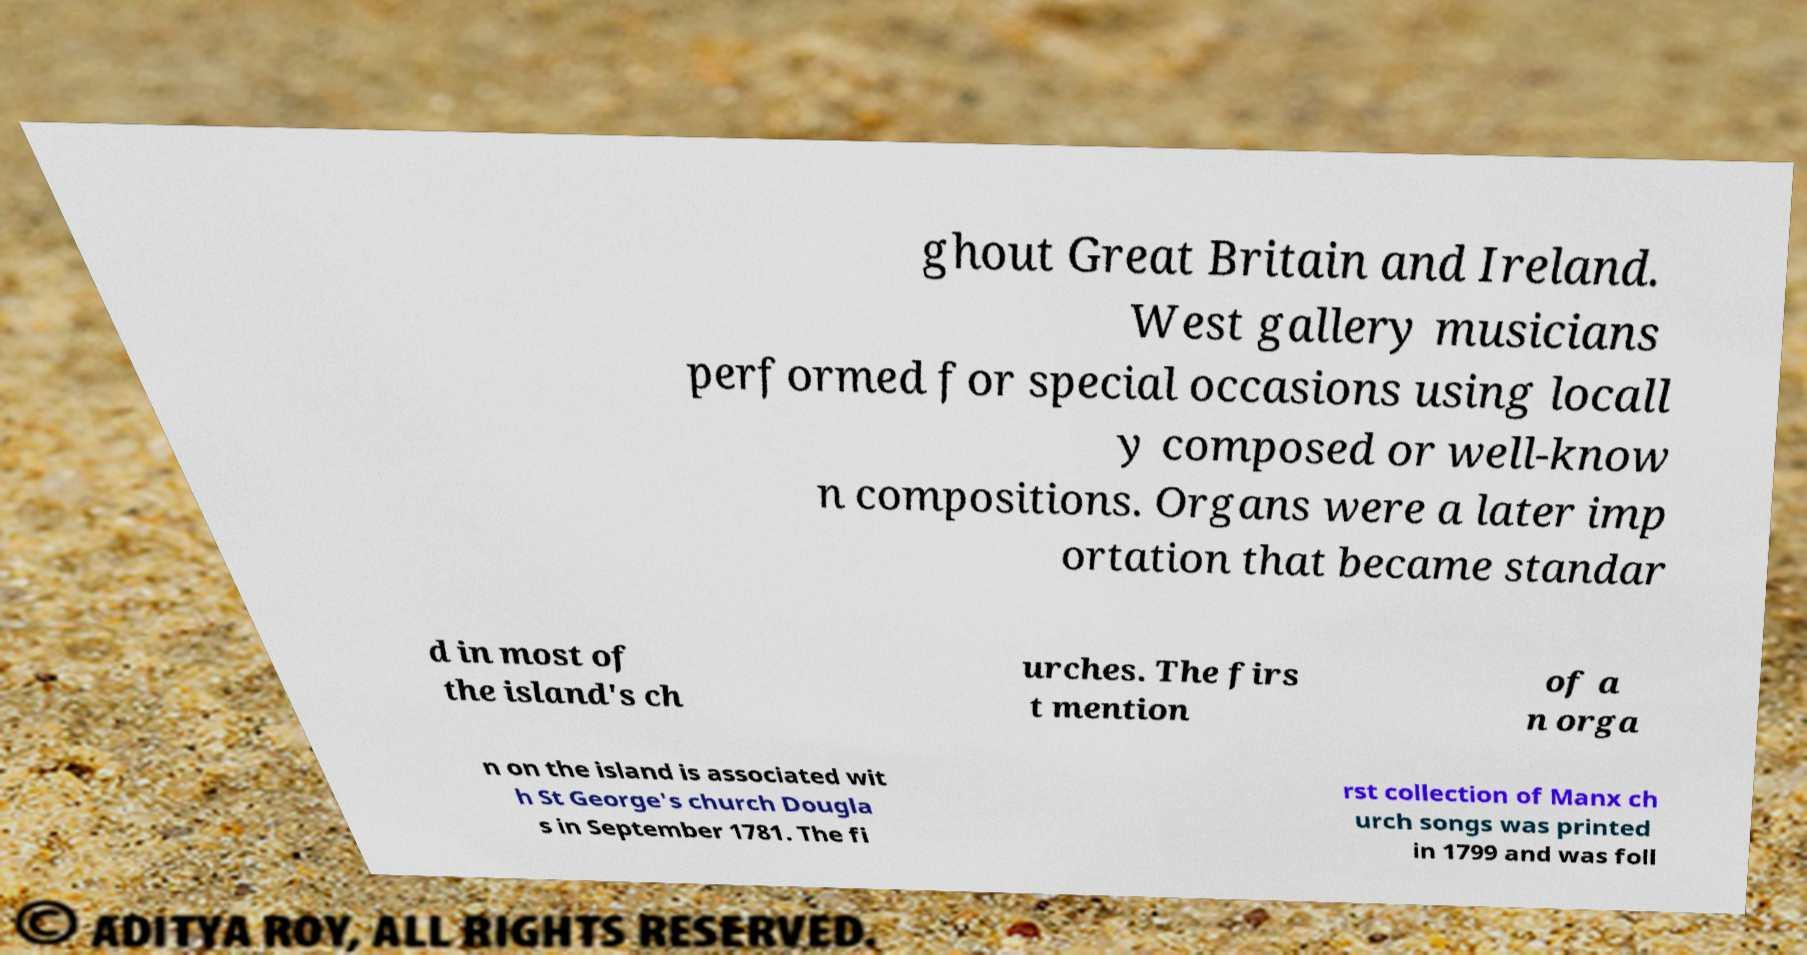There's text embedded in this image that I need extracted. Can you transcribe it verbatim? ghout Great Britain and Ireland. West gallery musicians performed for special occasions using locall y composed or well-know n compositions. Organs were a later imp ortation that became standar d in most of the island's ch urches. The firs t mention of a n orga n on the island is associated wit h St George's church Dougla s in September 1781. The fi rst collection of Manx ch urch songs was printed in 1799 and was foll 